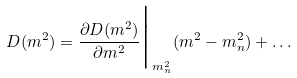<formula> <loc_0><loc_0><loc_500><loc_500>D ( m ^ { 2 } ) = \frac { \partial D ( m ^ { 2 } ) } { \partial m ^ { 2 } } \Big | _ { m _ { n } ^ { 2 } } ( m ^ { 2 } - m _ { n } ^ { 2 } ) + \dots</formula> 